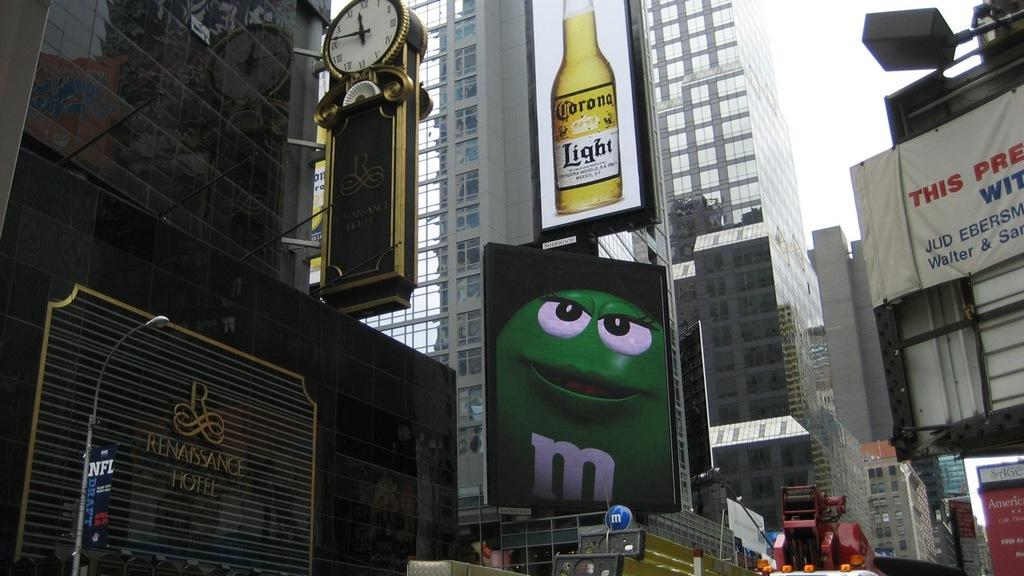<image>
Provide a brief description of the given image. an outside scene with advertising billboards for Corona Light and M&Ms 